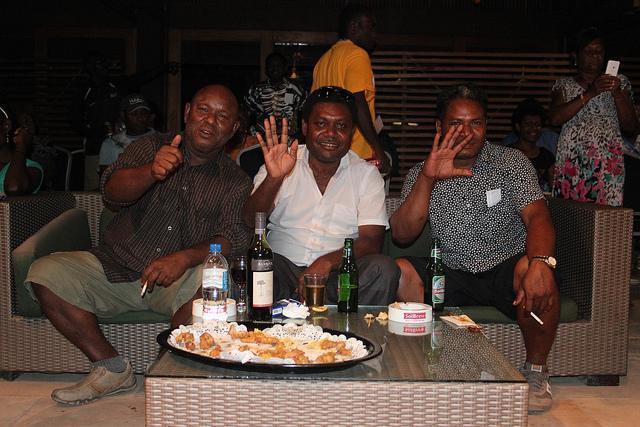How many men are sitting?
Give a very brief answer. 3. How many people are there?
Give a very brief answer. 9. How many bottles are there?
Give a very brief answer. 2. 